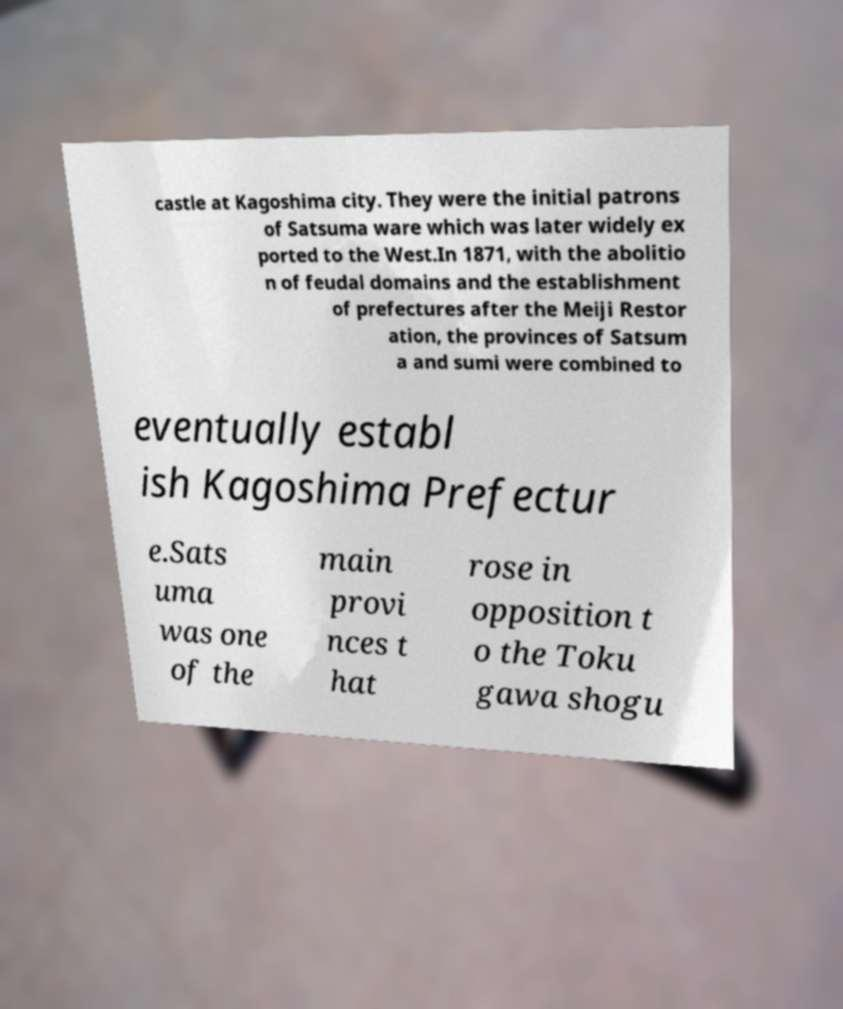For documentation purposes, I need the text within this image transcribed. Could you provide that? castle at Kagoshima city. They were the initial patrons of Satsuma ware which was later widely ex ported to the West.In 1871, with the abolitio n of feudal domains and the establishment of prefectures after the Meiji Restor ation, the provinces of Satsum a and sumi were combined to eventually establ ish Kagoshima Prefectur e.Sats uma was one of the main provi nces t hat rose in opposition t o the Toku gawa shogu 